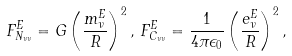Convert formula to latex. <formula><loc_0><loc_0><loc_500><loc_500>F ^ { E } _ { N _ { \nu \nu } } = G \left ( \frac { m _ { \nu } ^ { E } } { R } \right ) ^ { 2 } , \, F ^ { E } _ { C _ { \nu \nu } } = \frac { 1 } { 4 \pi \epsilon _ { 0 } } \left ( \frac { e _ { \nu } ^ { E } } { R } \right ) ^ { 2 } ,</formula> 